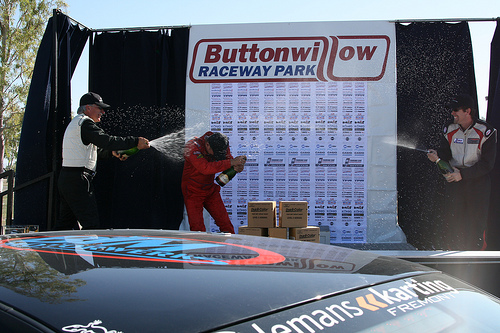<image>
Can you confirm if the box is on the car? No. The box is not positioned on the car. They may be near each other, but the box is not supported by or resting on top of the car. Is there a man to the left of the man? Yes. From this viewpoint, the man is positioned to the left side relative to the man. 